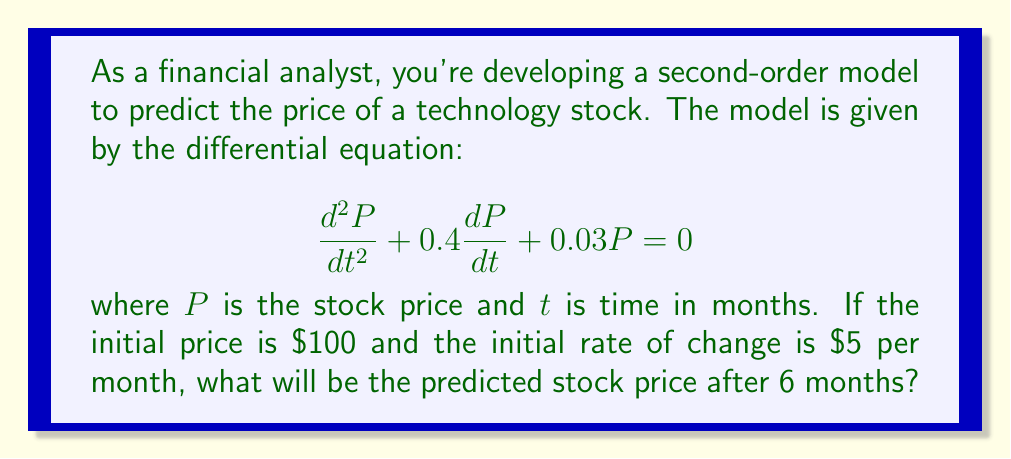Help me with this question. To solve this problem, we need to follow these steps:

1) The general solution for this second-order linear differential equation is:

   $$P(t) = C_1e^{r_1t} + C_2e^{r_2t}$$

   where $r_1$ and $r_2$ are the roots of the characteristic equation.

2) The characteristic equation is:
   
   $$r^2 + 0.4r + 0.03 = 0$$

3) Solving this quadratic equation:

   $$r = \frac{-0.4 \pm \sqrt{0.4^2 - 4(0.03)}}{2} = \frac{-0.4 \pm \sqrt{0.16 - 0.12}}{2} = \frac{-0.4 \pm \sqrt{0.04}}{2} = \frac{-0.4 \pm 0.2}{2}$$

   $$r_1 = -0.1 \text{ and } r_2 = -0.3$$

4) Therefore, the general solution is:

   $$P(t) = C_1e^{-0.1t} + C_2e^{-0.3t}$$

5) We need to find $C_1$ and $C_2$ using the initial conditions:
   
   At $t=0$, $P(0) = 100$ and $P'(0) = 5$

6) From $P(0) = 100$:
   
   $$100 = C_1 + C_2$$

7) From $P'(0) = 5$:
   
   $$5 = -0.1C_1 - 0.3C_2$$

8) Solving these simultaneous equations:

   $$C_1 = 150 \text{ and } C_2 = -50$$

9) Thus, the particular solution is:

   $$P(t) = 150e^{-0.1t} - 50e^{-0.3t}$$

10) To find the price after 6 months, we substitute $t=6$:

    $$P(6) = 150e^{-0.1(6)} - 50e^{-0.3(6)} = 150e^{-0.6} - 50e^{-1.8}$$

11) Calculating this:

    $$P(6) = 150(0.5488) - 50(0.1653) = 82.32 - 8.27 = 74.05$$
Answer: The predicted stock price after 6 months will be $\$74.05$. 